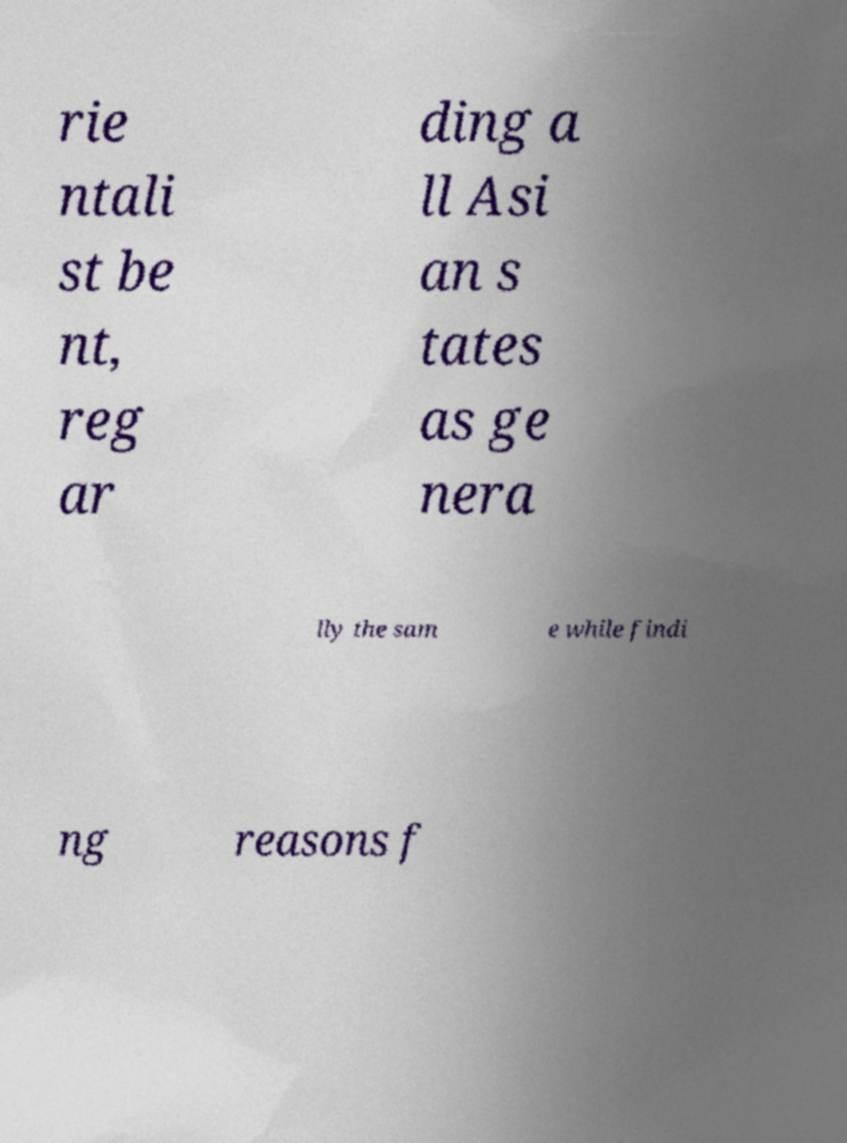Can you read and provide the text displayed in the image?This photo seems to have some interesting text. Can you extract and type it out for me? rie ntali st be nt, reg ar ding a ll Asi an s tates as ge nera lly the sam e while findi ng reasons f 